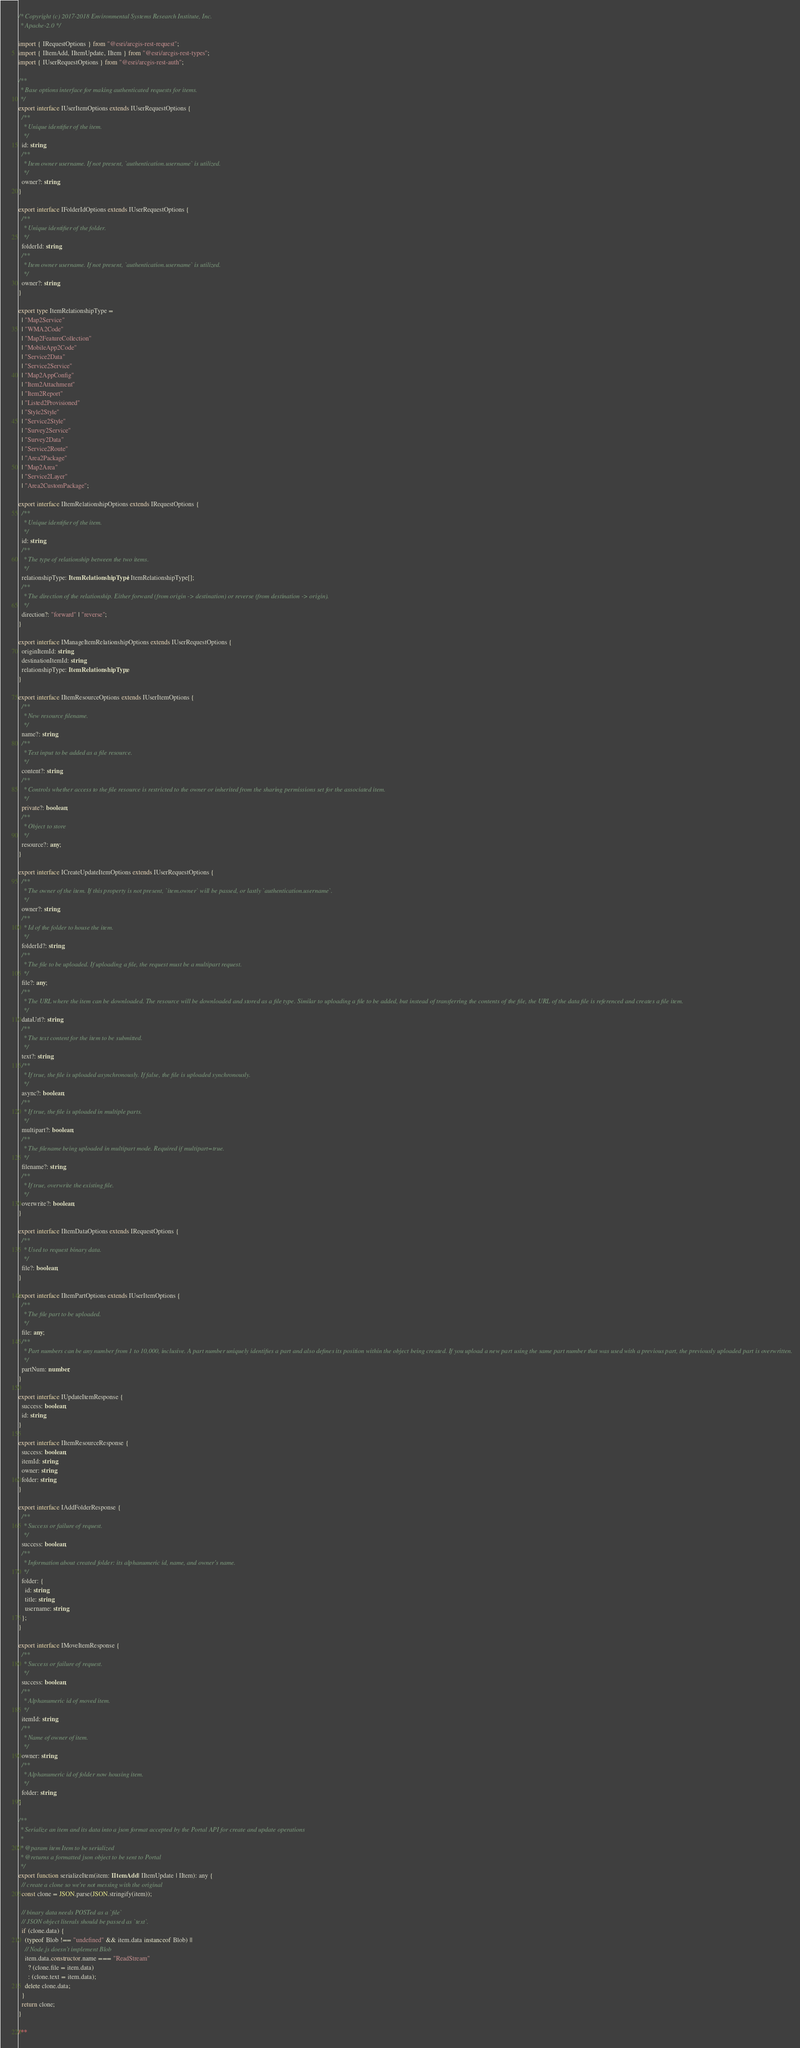<code> <loc_0><loc_0><loc_500><loc_500><_TypeScript_>/* Copyright (c) 2017-2018 Environmental Systems Research Institute, Inc.
 * Apache-2.0 */

import { IRequestOptions } from "@esri/arcgis-rest-request";
import { IItemAdd, IItemUpdate, IItem } from "@esri/arcgis-rest-types";
import { IUserRequestOptions } from "@esri/arcgis-rest-auth";

/**
 * Base options interface for making authenticated requests for items.
 */
export interface IUserItemOptions extends IUserRequestOptions {
  /**
   * Unique identifier of the item.
   */
  id: string;
  /**
   * Item owner username. If not present, `authentication.username` is utilized.
   */
  owner?: string;
}

export interface IFolderIdOptions extends IUserRequestOptions {
  /**
   * Unique identifier of the folder.
   */
  folderId: string;
  /**
   * Item owner username. If not present, `authentication.username` is utilized.
   */
  owner?: string;
}

export type ItemRelationshipType =
  | "Map2Service"
  | "WMA2Code"
  | "Map2FeatureCollection"
  | "MobileApp2Code"
  | "Service2Data"
  | "Service2Service"
  | "Map2AppConfig"
  | "Item2Attachment"
  | "Item2Report"
  | "Listed2Provisioned"
  | "Style2Style"
  | "Service2Style"
  | "Survey2Service"
  | "Survey2Data"
  | "Service2Route"
  | "Area2Package"
  | "Map2Area"
  | "Service2Layer"
  | "Area2CustomPackage";

export interface IItemRelationshipOptions extends IRequestOptions {
  /**
   * Unique identifier of the item.
   */
  id: string;
  /**
   * The type of relationship between the two items.
   */
  relationshipType: ItemRelationshipType | ItemRelationshipType[];
  /**
   * The direction of the relationship. Either forward (from origin -> destination) or reverse (from destination -> origin).
   */
  direction?: "forward" | "reverse";
}

export interface IManageItemRelationshipOptions extends IUserRequestOptions {
  originItemId: string;
  destinationItemId: string;
  relationshipType: ItemRelationshipType;
}

export interface IItemResourceOptions extends IUserItemOptions {
  /**
   * New resource filename.
   */
  name?: string;
  /**
   * Text input to be added as a file resource.
   */
  content?: string;
  /**
   * Controls whether access to the file resource is restricted to the owner or inherited from the sharing permissions set for the associated item.
   */
  private?: boolean;
  /**
   * Object to store
   */
  resource?: any;
}

export interface ICreateUpdateItemOptions extends IUserRequestOptions {
  /**
   * The owner of the item. If this property is not present, `item.owner` will be passed, or lastly `authentication.username`.
   */
  owner?: string;
  /**
   * Id of the folder to house the item.
   */
  folderId?: string;
  /**
   * The file to be uploaded. If uploading a file, the request must be a multipart request.
   */
  file?: any;
  /**
   * The URL where the item can be downloaded. The resource will be downloaded and stored as a file type. Similar to uploading a file to be added, but instead of transferring the contents of the file, the URL of the data file is referenced and creates a file item.
   */
  dataUrl?: string;
  /**
   * The text content for the item to be submitted.
   */
  text?: string;
  /**
   * If true, the file is uploaded asynchronously. If false, the file is uploaded synchronously.
   */
  async?: boolean;
  /**
   * If true, the file is uploaded in multiple parts.
   */
  multipart?: boolean;
  /**
   * The filename being uploaded in multipart mode. Required if multipart=true.
   */
  filename?: string;
  /**
   * If true, overwrite the existing file.
   */
  overwrite?: boolean;
}

export interface IItemDataOptions extends IRequestOptions {
  /**
   * Used to request binary data.
   */
  file?: boolean;
}

export interface IItemPartOptions extends IUserItemOptions {
  /**
   * The file part to be uploaded.
   */
  file: any;
  /**
   * Part numbers can be any number from 1 to 10,000, inclusive. A part number uniquely identifies a part and also defines its position within the object being created. If you upload a new part using the same part number that was used with a previous part, the previously uploaded part is overwritten.
   */
  partNum: number;
}

export interface IUpdateItemResponse {
  success: boolean;
  id: string;
}

export interface IItemResourceResponse {
  success: boolean;
  itemId: string;
  owner: string;
  folder: string;
}

export interface IAddFolderResponse {
  /**
   * Success or failure of request.
   */
  success: boolean;
  /**
   * Information about created folder: its alphanumeric id, name, and owner's name.
   */
  folder: {
    id: string;
    title: string;
    username: string;
  };
}

export interface IMoveItemResponse {
  /**
   * Success or failure of request.
   */
  success: boolean;
  /**
   * Alphanumeric id of moved item.
   */
  itemId: string;
  /**
   * Name of owner of item.
   */
  owner: string;
  /**
   * Alphanumeric id of folder now housing item.
   */
  folder: string;
}

/**
 * Serialize an item and its data into a json format accepted by the Portal API for create and update operations
 *
 * @param item Item to be serialized
 * @returns a formatted json object to be sent to Portal
 */
export function serializeItem(item: IItemAdd | IItemUpdate | IItem): any {
  // create a clone so we're not messing with the original
  const clone = JSON.parse(JSON.stringify(item));

  // binary data needs POSTed as a `file`
  // JSON object literals should be passed as `text`.
  if (clone.data) {
    (typeof Blob !== "undefined" && item.data instanceof Blob) ||
    // Node.js doesn't implement Blob
    item.data.constructor.name === "ReadStream"
      ? (clone.file = item.data)
      : (clone.text = item.data);
    delete clone.data;
  }
  return clone;
}

/**</code> 